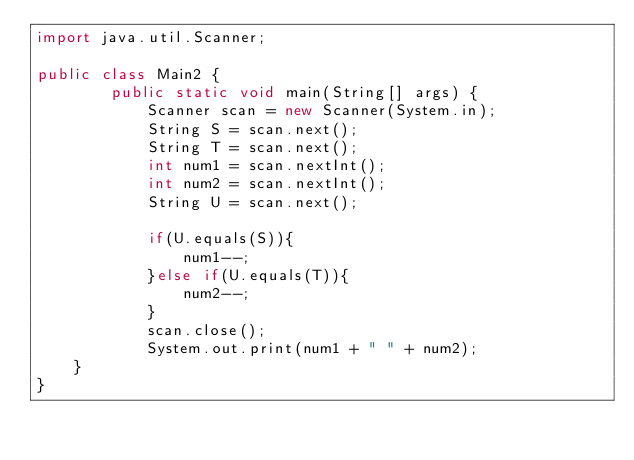<code> <loc_0><loc_0><loc_500><loc_500><_Java_>import java.util.Scanner;

public class Main2 {
	    public static void main(String[] args) {
	        Scanner scan = new Scanner(System.in);
	        String S = scan.next();
	        String T = scan.next();
	        int num1 = scan.nextInt();
	        int num2 = scan.nextInt();
	        String U = scan.next();

	        if(U.equals(S)){
	        	num1--;
	        }else if(U.equals(T)){
	         	num2--;
	        }
	        scan.close();
	      	System.out.print(num1 + " " + num2);
    }
}
</code> 